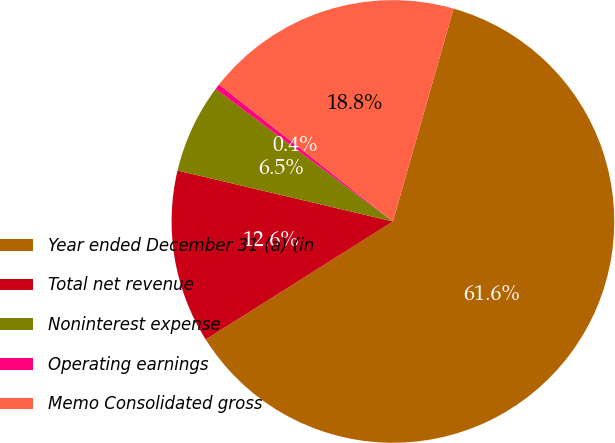<chart> <loc_0><loc_0><loc_500><loc_500><pie_chart><fcel>Year ended December 31 (a) (in<fcel>Total net revenue<fcel>Noninterest expense<fcel>Operating earnings<fcel>Memo Consolidated gross<nl><fcel>61.63%<fcel>12.65%<fcel>6.52%<fcel>0.4%<fcel>18.8%<nl></chart> 